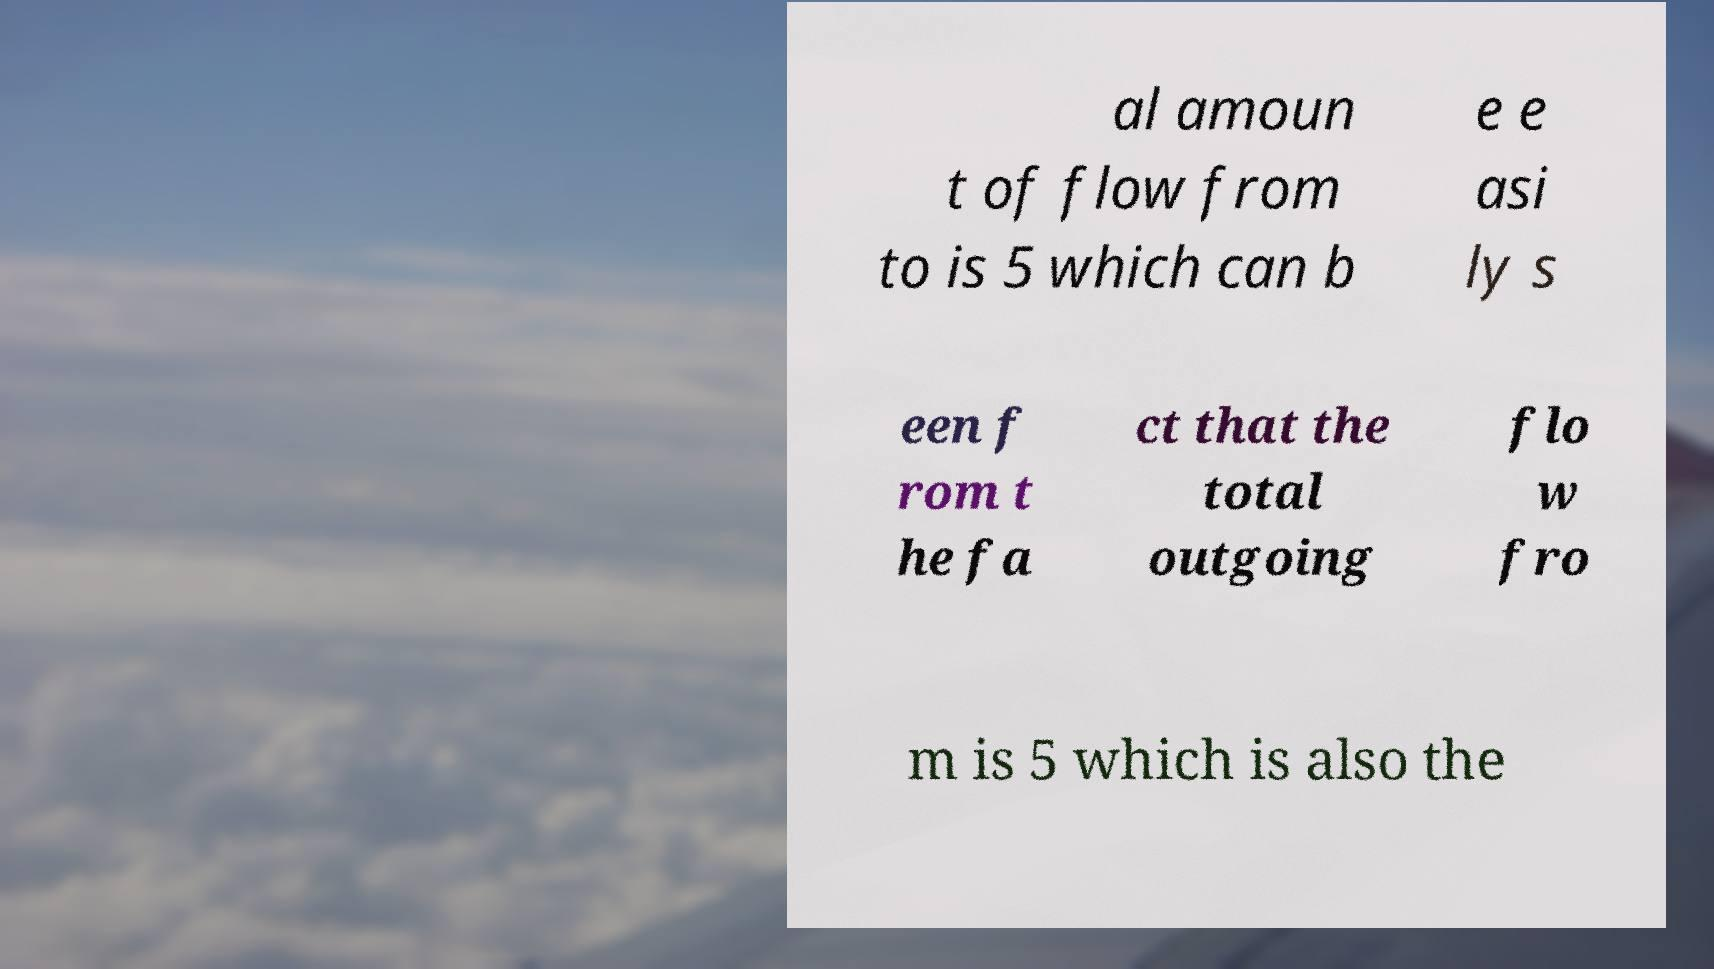Can you read and provide the text displayed in the image?This photo seems to have some interesting text. Can you extract and type it out for me? al amoun t of flow from to is 5 which can b e e asi ly s een f rom t he fa ct that the total outgoing flo w fro m is 5 which is also the 